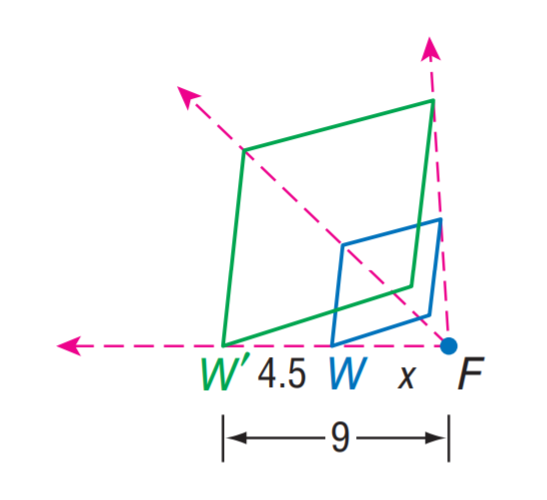Find the scale factor from W to W'. The correct answer to find the scale factor from W to W' is A: 2. When analyzing the scale between two geometric figures, you should compare the ratios of corresponding sides. In this case, W' appears to be half the size of W, indicating that the scale factor is indeed 2. 